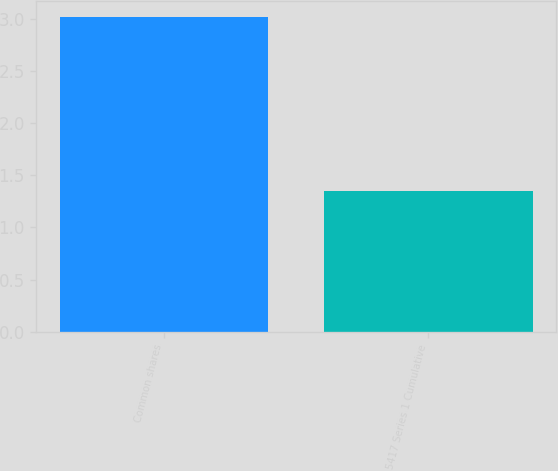Convert chart. <chart><loc_0><loc_0><loc_500><loc_500><bar_chart><fcel>Common shares<fcel>5417 Series 1 Cumulative<nl><fcel>3.02<fcel>1.35<nl></chart> 